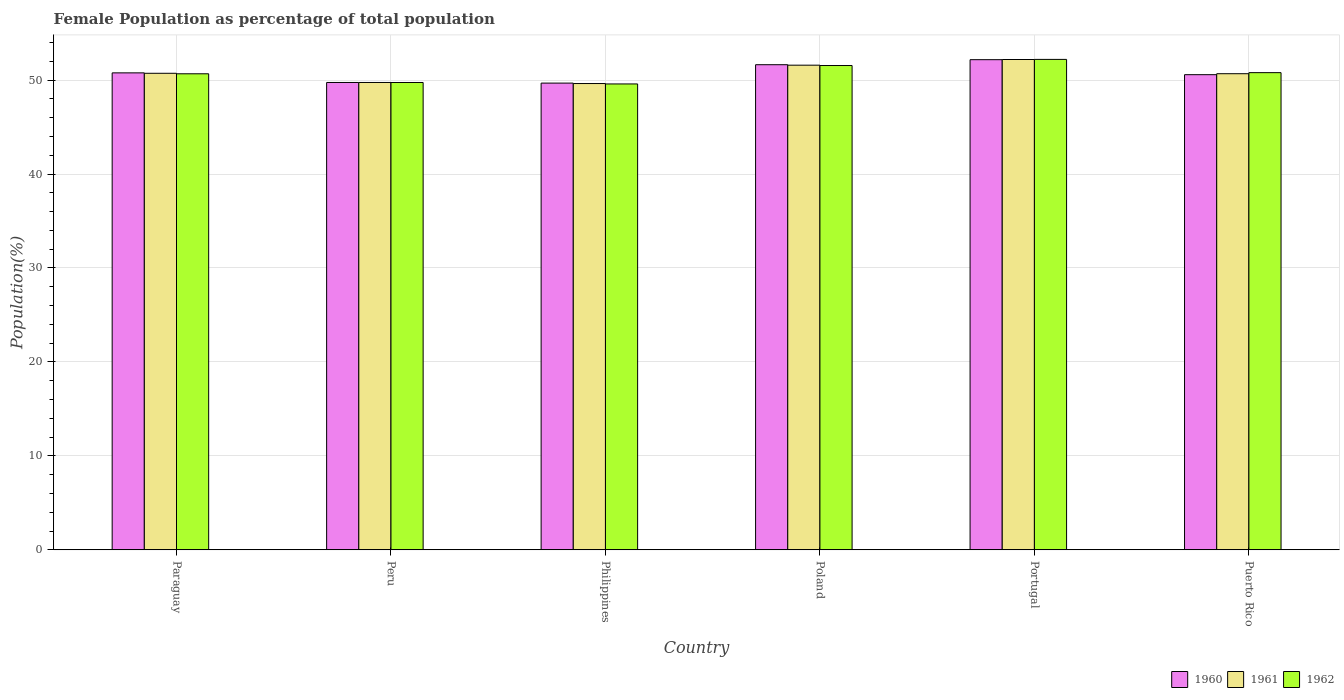How many bars are there on the 5th tick from the left?
Your answer should be compact. 3. How many bars are there on the 5th tick from the right?
Your answer should be very brief. 3. What is the label of the 1st group of bars from the left?
Make the answer very short. Paraguay. What is the female population in in 1960 in Puerto Rico?
Your response must be concise. 50.57. Across all countries, what is the maximum female population in in 1961?
Your answer should be compact. 52.19. Across all countries, what is the minimum female population in in 1961?
Provide a short and direct response. 49.63. In which country was the female population in in 1962 minimum?
Keep it short and to the point. Philippines. What is the total female population in in 1962 in the graph?
Offer a terse response. 304.52. What is the difference between the female population in in 1962 in Peru and that in Portugal?
Your answer should be very brief. -2.46. What is the difference between the female population in in 1960 in Peru and the female population in in 1962 in Philippines?
Your response must be concise. 0.16. What is the average female population in in 1961 per country?
Your response must be concise. 50.75. What is the difference between the female population in of/in 1961 and female population in of/in 1962 in Philippines?
Make the answer very short. 0.04. What is the ratio of the female population in in 1961 in Paraguay to that in Philippines?
Offer a terse response. 1.02. Is the difference between the female population in in 1961 in Philippines and Portugal greater than the difference between the female population in in 1962 in Philippines and Portugal?
Your answer should be compact. Yes. What is the difference between the highest and the second highest female population in in 1960?
Your answer should be compact. -0.87. What is the difference between the highest and the lowest female population in in 1961?
Offer a terse response. 2.56. Is the sum of the female population in in 1960 in Paraguay and Puerto Rico greater than the maximum female population in in 1962 across all countries?
Your answer should be compact. Yes. What does the 1st bar from the right in Philippines represents?
Provide a short and direct response. 1962. How many bars are there?
Provide a short and direct response. 18. Are all the bars in the graph horizontal?
Offer a terse response. No. How many countries are there in the graph?
Your answer should be compact. 6. What is the difference between two consecutive major ticks on the Y-axis?
Your answer should be compact. 10. Where does the legend appear in the graph?
Your answer should be very brief. Bottom right. How many legend labels are there?
Offer a terse response. 3. What is the title of the graph?
Keep it short and to the point. Female Population as percentage of total population. What is the label or title of the Y-axis?
Your answer should be very brief. Population(%). What is the Population(%) of 1960 in Paraguay?
Your response must be concise. 50.76. What is the Population(%) of 1961 in Paraguay?
Your response must be concise. 50.72. What is the Population(%) of 1962 in Paraguay?
Provide a succinct answer. 50.67. What is the Population(%) of 1960 in Peru?
Keep it short and to the point. 49.74. What is the Population(%) in 1961 in Peru?
Offer a terse response. 49.74. What is the Population(%) in 1962 in Peru?
Make the answer very short. 49.74. What is the Population(%) of 1960 in Philippines?
Keep it short and to the point. 49.67. What is the Population(%) of 1961 in Philippines?
Give a very brief answer. 49.63. What is the Population(%) of 1962 in Philippines?
Provide a succinct answer. 49.58. What is the Population(%) in 1960 in Poland?
Offer a terse response. 51.63. What is the Population(%) in 1961 in Poland?
Make the answer very short. 51.58. What is the Population(%) of 1962 in Poland?
Provide a short and direct response. 51.55. What is the Population(%) in 1960 in Portugal?
Provide a short and direct response. 52.17. What is the Population(%) of 1961 in Portugal?
Offer a terse response. 52.19. What is the Population(%) of 1962 in Portugal?
Provide a succinct answer. 52.2. What is the Population(%) in 1960 in Puerto Rico?
Give a very brief answer. 50.57. What is the Population(%) in 1961 in Puerto Rico?
Ensure brevity in your answer.  50.67. What is the Population(%) of 1962 in Puerto Rico?
Your response must be concise. 50.79. Across all countries, what is the maximum Population(%) in 1960?
Ensure brevity in your answer.  52.17. Across all countries, what is the maximum Population(%) of 1961?
Make the answer very short. 52.19. Across all countries, what is the maximum Population(%) in 1962?
Offer a terse response. 52.2. Across all countries, what is the minimum Population(%) of 1960?
Your response must be concise. 49.67. Across all countries, what is the minimum Population(%) of 1961?
Give a very brief answer. 49.63. Across all countries, what is the minimum Population(%) of 1962?
Your answer should be compact. 49.58. What is the total Population(%) of 1960 in the graph?
Provide a succinct answer. 304.55. What is the total Population(%) in 1961 in the graph?
Offer a terse response. 304.53. What is the total Population(%) of 1962 in the graph?
Your answer should be compact. 304.52. What is the difference between the Population(%) of 1960 in Paraguay and that in Peru?
Provide a short and direct response. 1.02. What is the difference between the Population(%) of 1962 in Paraguay and that in Peru?
Your answer should be very brief. 0.93. What is the difference between the Population(%) in 1960 in Paraguay and that in Philippines?
Offer a terse response. 1.09. What is the difference between the Population(%) in 1961 in Paraguay and that in Philippines?
Your answer should be very brief. 1.09. What is the difference between the Population(%) of 1962 in Paraguay and that in Philippines?
Make the answer very short. 1.08. What is the difference between the Population(%) in 1960 in Paraguay and that in Poland?
Make the answer very short. -0.87. What is the difference between the Population(%) of 1961 in Paraguay and that in Poland?
Ensure brevity in your answer.  -0.86. What is the difference between the Population(%) in 1962 in Paraguay and that in Poland?
Give a very brief answer. -0.88. What is the difference between the Population(%) in 1960 in Paraguay and that in Portugal?
Offer a very short reply. -1.4. What is the difference between the Population(%) in 1961 in Paraguay and that in Portugal?
Provide a succinct answer. -1.47. What is the difference between the Population(%) of 1962 in Paraguay and that in Portugal?
Your answer should be very brief. -1.53. What is the difference between the Population(%) in 1960 in Paraguay and that in Puerto Rico?
Offer a terse response. 0.19. What is the difference between the Population(%) of 1961 in Paraguay and that in Puerto Rico?
Keep it short and to the point. 0.04. What is the difference between the Population(%) of 1962 in Paraguay and that in Puerto Rico?
Keep it short and to the point. -0.12. What is the difference between the Population(%) of 1960 in Peru and that in Philippines?
Provide a succinct answer. 0.07. What is the difference between the Population(%) of 1961 in Peru and that in Philippines?
Offer a very short reply. 0.11. What is the difference between the Population(%) of 1962 in Peru and that in Philippines?
Your answer should be compact. 0.16. What is the difference between the Population(%) in 1960 in Peru and that in Poland?
Keep it short and to the point. -1.89. What is the difference between the Population(%) of 1961 in Peru and that in Poland?
Provide a short and direct response. -1.84. What is the difference between the Population(%) in 1962 in Peru and that in Poland?
Keep it short and to the point. -1.81. What is the difference between the Population(%) of 1960 in Peru and that in Portugal?
Your answer should be very brief. -2.43. What is the difference between the Population(%) in 1961 in Peru and that in Portugal?
Offer a terse response. -2.44. What is the difference between the Population(%) in 1962 in Peru and that in Portugal?
Ensure brevity in your answer.  -2.46. What is the difference between the Population(%) in 1960 in Peru and that in Puerto Rico?
Offer a very short reply. -0.83. What is the difference between the Population(%) in 1961 in Peru and that in Puerto Rico?
Offer a very short reply. -0.93. What is the difference between the Population(%) of 1962 in Peru and that in Puerto Rico?
Ensure brevity in your answer.  -1.05. What is the difference between the Population(%) of 1960 in Philippines and that in Poland?
Make the answer very short. -1.96. What is the difference between the Population(%) in 1961 in Philippines and that in Poland?
Ensure brevity in your answer.  -1.95. What is the difference between the Population(%) of 1962 in Philippines and that in Poland?
Offer a terse response. -1.96. What is the difference between the Population(%) in 1960 in Philippines and that in Portugal?
Keep it short and to the point. -2.49. What is the difference between the Population(%) of 1961 in Philippines and that in Portugal?
Offer a terse response. -2.56. What is the difference between the Population(%) of 1962 in Philippines and that in Portugal?
Your answer should be very brief. -2.61. What is the difference between the Population(%) in 1960 in Philippines and that in Puerto Rico?
Offer a terse response. -0.9. What is the difference between the Population(%) of 1961 in Philippines and that in Puerto Rico?
Make the answer very short. -1.05. What is the difference between the Population(%) of 1962 in Philippines and that in Puerto Rico?
Make the answer very short. -1.2. What is the difference between the Population(%) of 1960 in Poland and that in Portugal?
Make the answer very short. -0.54. What is the difference between the Population(%) of 1961 in Poland and that in Portugal?
Ensure brevity in your answer.  -0.6. What is the difference between the Population(%) of 1962 in Poland and that in Portugal?
Provide a short and direct response. -0.65. What is the difference between the Population(%) in 1960 in Poland and that in Puerto Rico?
Make the answer very short. 1.06. What is the difference between the Population(%) in 1961 in Poland and that in Puerto Rico?
Your response must be concise. 0.91. What is the difference between the Population(%) of 1962 in Poland and that in Puerto Rico?
Provide a short and direct response. 0.76. What is the difference between the Population(%) of 1960 in Portugal and that in Puerto Rico?
Your answer should be compact. 1.6. What is the difference between the Population(%) of 1961 in Portugal and that in Puerto Rico?
Provide a short and direct response. 1.51. What is the difference between the Population(%) in 1962 in Portugal and that in Puerto Rico?
Keep it short and to the point. 1.41. What is the difference between the Population(%) of 1960 in Paraguay and the Population(%) of 1961 in Peru?
Your answer should be compact. 1.02. What is the difference between the Population(%) of 1960 in Paraguay and the Population(%) of 1962 in Peru?
Provide a succinct answer. 1.02. What is the difference between the Population(%) of 1961 in Paraguay and the Population(%) of 1962 in Peru?
Offer a terse response. 0.98. What is the difference between the Population(%) of 1960 in Paraguay and the Population(%) of 1961 in Philippines?
Provide a succinct answer. 1.14. What is the difference between the Population(%) in 1960 in Paraguay and the Population(%) in 1962 in Philippines?
Your answer should be compact. 1.18. What is the difference between the Population(%) of 1961 in Paraguay and the Population(%) of 1962 in Philippines?
Provide a short and direct response. 1.13. What is the difference between the Population(%) in 1960 in Paraguay and the Population(%) in 1961 in Poland?
Give a very brief answer. -0.82. What is the difference between the Population(%) in 1960 in Paraguay and the Population(%) in 1962 in Poland?
Your answer should be compact. -0.78. What is the difference between the Population(%) of 1961 in Paraguay and the Population(%) of 1962 in Poland?
Offer a terse response. -0.83. What is the difference between the Population(%) in 1960 in Paraguay and the Population(%) in 1961 in Portugal?
Give a very brief answer. -1.42. What is the difference between the Population(%) of 1960 in Paraguay and the Population(%) of 1962 in Portugal?
Offer a very short reply. -1.43. What is the difference between the Population(%) of 1961 in Paraguay and the Population(%) of 1962 in Portugal?
Give a very brief answer. -1.48. What is the difference between the Population(%) of 1960 in Paraguay and the Population(%) of 1961 in Puerto Rico?
Your answer should be compact. 0.09. What is the difference between the Population(%) of 1960 in Paraguay and the Population(%) of 1962 in Puerto Rico?
Provide a succinct answer. -0.02. What is the difference between the Population(%) of 1961 in Paraguay and the Population(%) of 1962 in Puerto Rico?
Your response must be concise. -0.07. What is the difference between the Population(%) in 1960 in Peru and the Population(%) in 1961 in Philippines?
Make the answer very short. 0.11. What is the difference between the Population(%) of 1960 in Peru and the Population(%) of 1962 in Philippines?
Provide a short and direct response. 0.16. What is the difference between the Population(%) of 1961 in Peru and the Population(%) of 1962 in Philippines?
Your answer should be very brief. 0.16. What is the difference between the Population(%) in 1960 in Peru and the Population(%) in 1961 in Poland?
Offer a terse response. -1.84. What is the difference between the Population(%) of 1960 in Peru and the Population(%) of 1962 in Poland?
Your answer should be compact. -1.8. What is the difference between the Population(%) in 1961 in Peru and the Population(%) in 1962 in Poland?
Provide a short and direct response. -1.81. What is the difference between the Population(%) in 1960 in Peru and the Population(%) in 1961 in Portugal?
Offer a very short reply. -2.44. What is the difference between the Population(%) in 1960 in Peru and the Population(%) in 1962 in Portugal?
Provide a short and direct response. -2.46. What is the difference between the Population(%) in 1961 in Peru and the Population(%) in 1962 in Portugal?
Make the answer very short. -2.46. What is the difference between the Population(%) in 1960 in Peru and the Population(%) in 1961 in Puerto Rico?
Provide a succinct answer. -0.93. What is the difference between the Population(%) in 1960 in Peru and the Population(%) in 1962 in Puerto Rico?
Provide a succinct answer. -1.05. What is the difference between the Population(%) in 1961 in Peru and the Population(%) in 1962 in Puerto Rico?
Provide a succinct answer. -1.05. What is the difference between the Population(%) in 1960 in Philippines and the Population(%) in 1961 in Poland?
Provide a short and direct response. -1.91. What is the difference between the Population(%) of 1960 in Philippines and the Population(%) of 1962 in Poland?
Make the answer very short. -1.87. What is the difference between the Population(%) of 1961 in Philippines and the Population(%) of 1962 in Poland?
Give a very brief answer. -1.92. What is the difference between the Population(%) in 1960 in Philippines and the Population(%) in 1961 in Portugal?
Offer a terse response. -2.51. What is the difference between the Population(%) of 1960 in Philippines and the Population(%) of 1962 in Portugal?
Your response must be concise. -2.52. What is the difference between the Population(%) in 1961 in Philippines and the Population(%) in 1962 in Portugal?
Provide a short and direct response. -2.57. What is the difference between the Population(%) of 1960 in Philippines and the Population(%) of 1961 in Puerto Rico?
Ensure brevity in your answer.  -1. What is the difference between the Population(%) of 1960 in Philippines and the Population(%) of 1962 in Puerto Rico?
Offer a very short reply. -1.11. What is the difference between the Population(%) in 1961 in Philippines and the Population(%) in 1962 in Puerto Rico?
Ensure brevity in your answer.  -1.16. What is the difference between the Population(%) in 1960 in Poland and the Population(%) in 1961 in Portugal?
Provide a succinct answer. -0.55. What is the difference between the Population(%) in 1960 in Poland and the Population(%) in 1962 in Portugal?
Offer a very short reply. -0.57. What is the difference between the Population(%) of 1961 in Poland and the Population(%) of 1962 in Portugal?
Offer a very short reply. -0.62. What is the difference between the Population(%) of 1960 in Poland and the Population(%) of 1961 in Puerto Rico?
Offer a very short reply. 0.96. What is the difference between the Population(%) of 1960 in Poland and the Population(%) of 1962 in Puerto Rico?
Make the answer very short. 0.84. What is the difference between the Population(%) of 1961 in Poland and the Population(%) of 1962 in Puerto Rico?
Offer a very short reply. 0.79. What is the difference between the Population(%) in 1960 in Portugal and the Population(%) in 1961 in Puerto Rico?
Offer a terse response. 1.49. What is the difference between the Population(%) of 1960 in Portugal and the Population(%) of 1962 in Puerto Rico?
Provide a succinct answer. 1.38. What is the difference between the Population(%) in 1961 in Portugal and the Population(%) in 1962 in Puerto Rico?
Your answer should be compact. 1.4. What is the average Population(%) in 1960 per country?
Keep it short and to the point. 50.76. What is the average Population(%) of 1961 per country?
Provide a succinct answer. 50.75. What is the average Population(%) in 1962 per country?
Ensure brevity in your answer.  50.75. What is the difference between the Population(%) of 1960 and Population(%) of 1961 in Paraguay?
Provide a short and direct response. 0.05. What is the difference between the Population(%) of 1960 and Population(%) of 1962 in Paraguay?
Your response must be concise. 0.1. What is the difference between the Population(%) of 1961 and Population(%) of 1962 in Paraguay?
Your answer should be compact. 0.05. What is the difference between the Population(%) in 1960 and Population(%) in 1961 in Peru?
Your answer should be compact. 0. What is the difference between the Population(%) of 1960 and Population(%) of 1961 in Philippines?
Your response must be concise. 0.05. What is the difference between the Population(%) in 1960 and Population(%) in 1962 in Philippines?
Give a very brief answer. 0.09. What is the difference between the Population(%) of 1961 and Population(%) of 1962 in Philippines?
Offer a terse response. 0.04. What is the difference between the Population(%) of 1960 and Population(%) of 1961 in Poland?
Make the answer very short. 0.05. What is the difference between the Population(%) in 1960 and Population(%) in 1962 in Poland?
Ensure brevity in your answer.  0.09. What is the difference between the Population(%) of 1961 and Population(%) of 1962 in Poland?
Make the answer very short. 0.04. What is the difference between the Population(%) of 1960 and Population(%) of 1961 in Portugal?
Your answer should be compact. -0.02. What is the difference between the Population(%) of 1960 and Population(%) of 1962 in Portugal?
Your answer should be compact. -0.03. What is the difference between the Population(%) in 1961 and Population(%) in 1962 in Portugal?
Keep it short and to the point. -0.01. What is the difference between the Population(%) of 1960 and Population(%) of 1961 in Puerto Rico?
Make the answer very short. -0.1. What is the difference between the Population(%) of 1960 and Population(%) of 1962 in Puerto Rico?
Your answer should be very brief. -0.22. What is the difference between the Population(%) of 1961 and Population(%) of 1962 in Puerto Rico?
Ensure brevity in your answer.  -0.11. What is the ratio of the Population(%) in 1960 in Paraguay to that in Peru?
Your answer should be very brief. 1.02. What is the ratio of the Population(%) of 1961 in Paraguay to that in Peru?
Offer a terse response. 1.02. What is the ratio of the Population(%) in 1962 in Paraguay to that in Peru?
Your answer should be very brief. 1.02. What is the ratio of the Population(%) in 1960 in Paraguay to that in Philippines?
Your answer should be very brief. 1.02. What is the ratio of the Population(%) of 1961 in Paraguay to that in Philippines?
Give a very brief answer. 1.02. What is the ratio of the Population(%) in 1962 in Paraguay to that in Philippines?
Provide a short and direct response. 1.02. What is the ratio of the Population(%) of 1960 in Paraguay to that in Poland?
Your answer should be compact. 0.98. What is the ratio of the Population(%) of 1961 in Paraguay to that in Poland?
Give a very brief answer. 0.98. What is the ratio of the Population(%) in 1962 in Paraguay to that in Poland?
Ensure brevity in your answer.  0.98. What is the ratio of the Population(%) of 1960 in Paraguay to that in Portugal?
Make the answer very short. 0.97. What is the ratio of the Population(%) of 1961 in Paraguay to that in Portugal?
Your response must be concise. 0.97. What is the ratio of the Population(%) of 1962 in Paraguay to that in Portugal?
Make the answer very short. 0.97. What is the ratio of the Population(%) of 1962 in Paraguay to that in Puerto Rico?
Offer a very short reply. 1. What is the ratio of the Population(%) of 1960 in Peru to that in Philippines?
Ensure brevity in your answer.  1. What is the ratio of the Population(%) in 1962 in Peru to that in Philippines?
Ensure brevity in your answer.  1. What is the ratio of the Population(%) of 1960 in Peru to that in Poland?
Offer a very short reply. 0.96. What is the ratio of the Population(%) in 1960 in Peru to that in Portugal?
Your answer should be compact. 0.95. What is the ratio of the Population(%) in 1961 in Peru to that in Portugal?
Make the answer very short. 0.95. What is the ratio of the Population(%) of 1962 in Peru to that in Portugal?
Provide a succinct answer. 0.95. What is the ratio of the Population(%) in 1960 in Peru to that in Puerto Rico?
Give a very brief answer. 0.98. What is the ratio of the Population(%) of 1961 in Peru to that in Puerto Rico?
Your response must be concise. 0.98. What is the ratio of the Population(%) of 1962 in Peru to that in Puerto Rico?
Your answer should be very brief. 0.98. What is the ratio of the Population(%) in 1960 in Philippines to that in Poland?
Keep it short and to the point. 0.96. What is the ratio of the Population(%) in 1961 in Philippines to that in Poland?
Provide a succinct answer. 0.96. What is the ratio of the Population(%) in 1962 in Philippines to that in Poland?
Ensure brevity in your answer.  0.96. What is the ratio of the Population(%) in 1960 in Philippines to that in Portugal?
Offer a very short reply. 0.95. What is the ratio of the Population(%) in 1961 in Philippines to that in Portugal?
Keep it short and to the point. 0.95. What is the ratio of the Population(%) of 1962 in Philippines to that in Portugal?
Offer a very short reply. 0.95. What is the ratio of the Population(%) in 1960 in Philippines to that in Puerto Rico?
Your answer should be compact. 0.98. What is the ratio of the Population(%) of 1961 in Philippines to that in Puerto Rico?
Keep it short and to the point. 0.98. What is the ratio of the Population(%) of 1962 in Philippines to that in Puerto Rico?
Keep it short and to the point. 0.98. What is the ratio of the Population(%) of 1961 in Poland to that in Portugal?
Provide a short and direct response. 0.99. What is the ratio of the Population(%) in 1962 in Poland to that in Portugal?
Offer a very short reply. 0.99. What is the ratio of the Population(%) of 1960 in Poland to that in Puerto Rico?
Provide a short and direct response. 1.02. What is the ratio of the Population(%) in 1961 in Poland to that in Puerto Rico?
Give a very brief answer. 1.02. What is the ratio of the Population(%) of 1962 in Poland to that in Puerto Rico?
Your answer should be very brief. 1.01. What is the ratio of the Population(%) in 1960 in Portugal to that in Puerto Rico?
Offer a very short reply. 1.03. What is the ratio of the Population(%) in 1961 in Portugal to that in Puerto Rico?
Keep it short and to the point. 1.03. What is the ratio of the Population(%) in 1962 in Portugal to that in Puerto Rico?
Ensure brevity in your answer.  1.03. What is the difference between the highest and the second highest Population(%) of 1960?
Your answer should be compact. 0.54. What is the difference between the highest and the second highest Population(%) of 1961?
Provide a short and direct response. 0.6. What is the difference between the highest and the second highest Population(%) of 1962?
Provide a short and direct response. 0.65. What is the difference between the highest and the lowest Population(%) of 1960?
Offer a terse response. 2.49. What is the difference between the highest and the lowest Population(%) in 1961?
Provide a succinct answer. 2.56. What is the difference between the highest and the lowest Population(%) in 1962?
Offer a terse response. 2.61. 